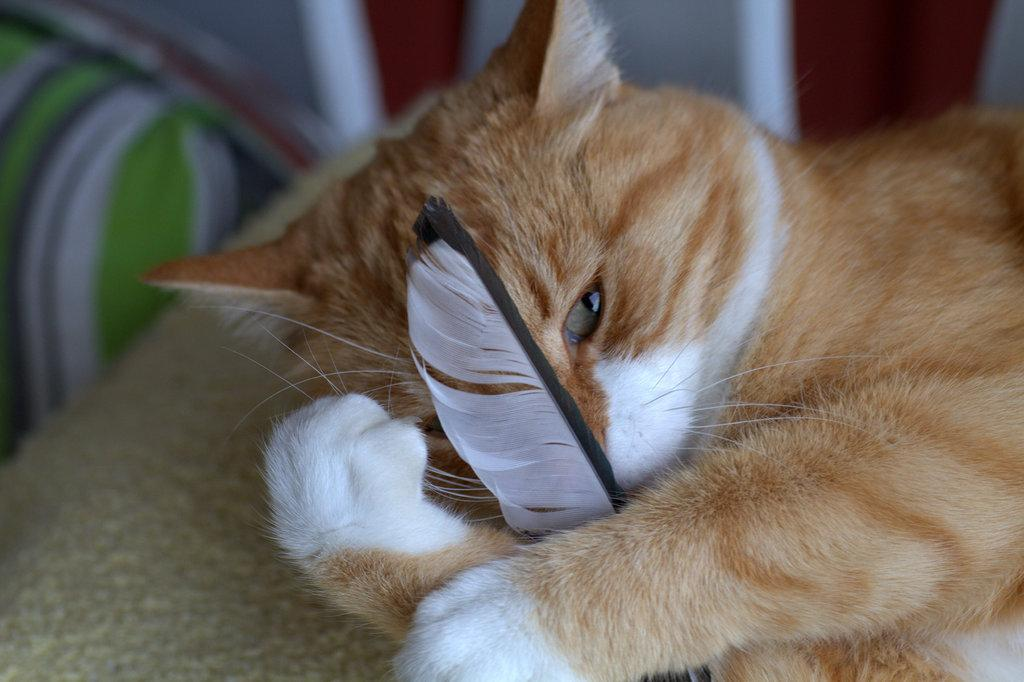What type of animal is in the image? There is a cat in the image. What is the cat doing in the image? The cat is laying down. What is the cat holding in the image? The cat is holding an object. What type of silver clock can be seen in the image? There is no silver clock present in the image; it features a cat laying down and holding an object. What fictional character is interacting with the cat in the image? There are no fictional characters present in the image; it only features a cat. 